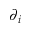Convert formula to latex. <formula><loc_0><loc_0><loc_500><loc_500>\partial _ { i }</formula> 